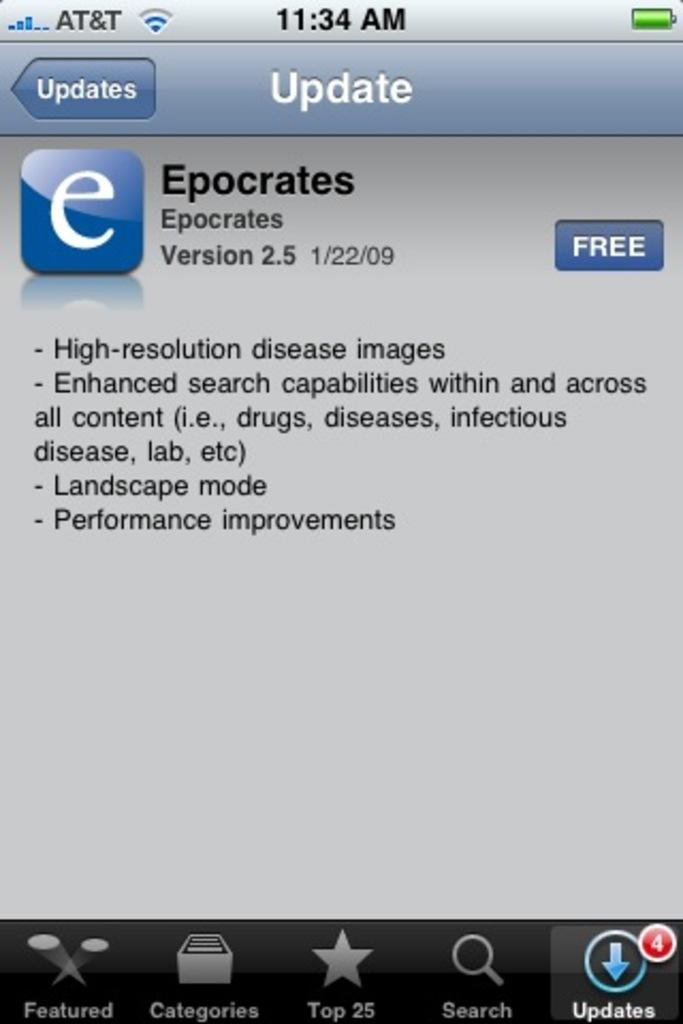<image>
Describe the image concisely. Phone screen that has 4 Updates that need to be downloaded. 